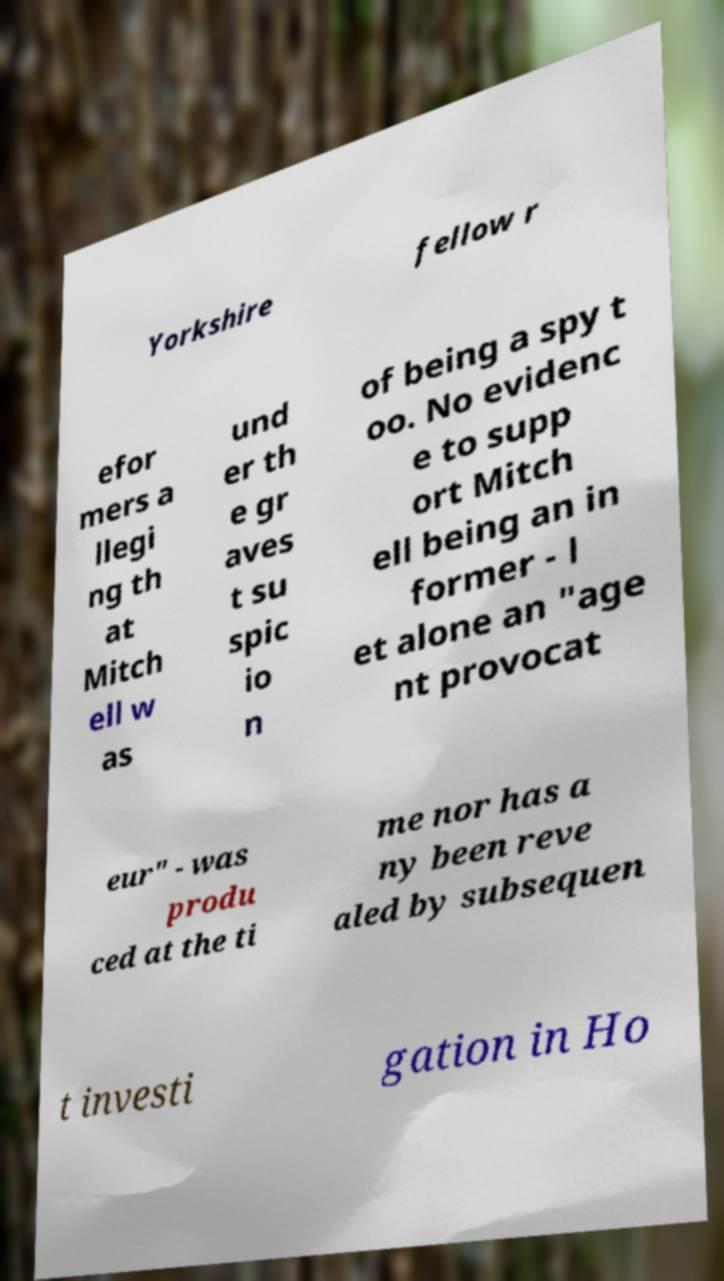Please identify and transcribe the text found in this image. Yorkshire fellow r efor mers a llegi ng th at Mitch ell w as und er th e gr aves t su spic io n of being a spy t oo. No evidenc e to supp ort Mitch ell being an in former - l et alone an "age nt provocat eur" - was produ ced at the ti me nor has a ny been reve aled by subsequen t investi gation in Ho 